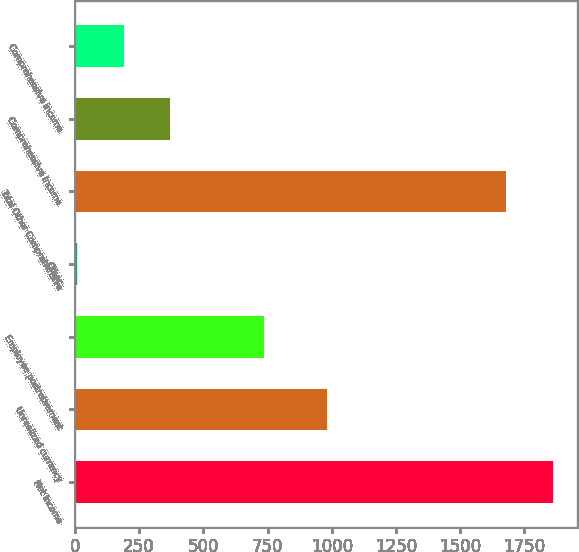Convert chart. <chart><loc_0><loc_0><loc_500><loc_500><bar_chart><fcel>Net Income<fcel>Unrealized currency<fcel>Employee postretirement<fcel>Other<fcel>Total Other Comprehensive<fcel>Comprehensive Income<fcel>Comprehensive income<nl><fcel>1861.1<fcel>982<fcel>736.4<fcel>8<fcel>1679<fcel>372.2<fcel>190.1<nl></chart> 